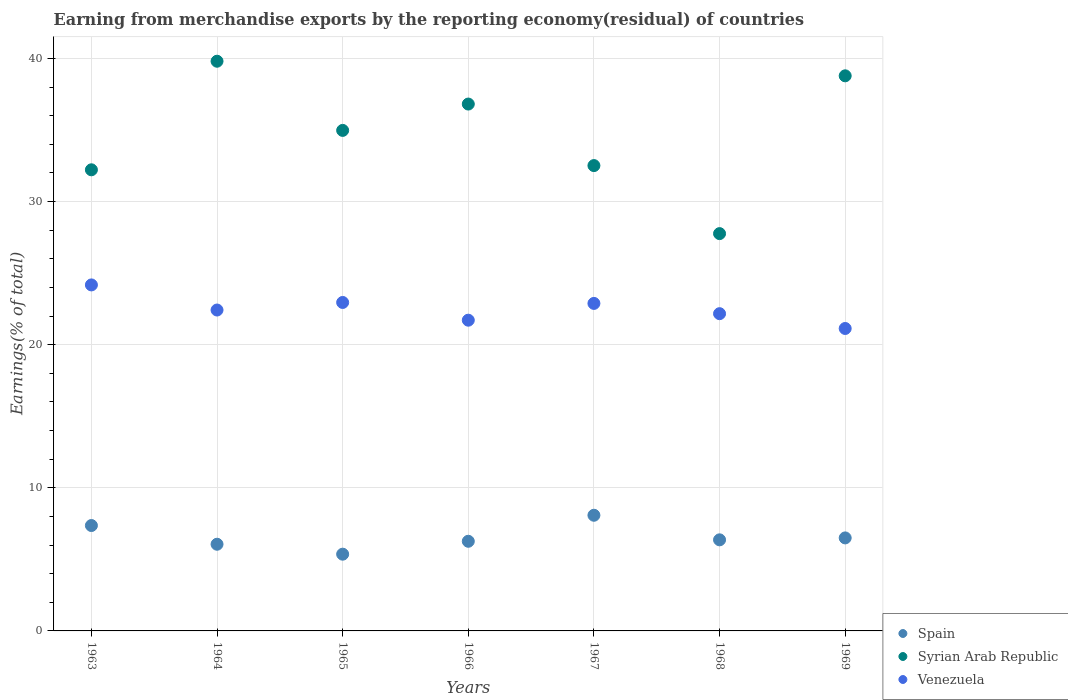What is the percentage of amount earned from merchandise exports in Venezuela in 1963?
Offer a terse response. 24.18. Across all years, what is the maximum percentage of amount earned from merchandise exports in Syrian Arab Republic?
Your response must be concise. 39.81. Across all years, what is the minimum percentage of amount earned from merchandise exports in Venezuela?
Your response must be concise. 21.13. In which year was the percentage of amount earned from merchandise exports in Syrian Arab Republic maximum?
Offer a very short reply. 1964. In which year was the percentage of amount earned from merchandise exports in Spain minimum?
Offer a terse response. 1965. What is the total percentage of amount earned from merchandise exports in Syrian Arab Republic in the graph?
Your answer should be compact. 242.88. What is the difference between the percentage of amount earned from merchandise exports in Syrian Arab Republic in 1964 and that in 1969?
Offer a very short reply. 1.02. What is the difference between the percentage of amount earned from merchandise exports in Venezuela in 1966 and the percentage of amount earned from merchandise exports in Spain in 1963?
Your answer should be very brief. 14.35. What is the average percentage of amount earned from merchandise exports in Venezuela per year?
Provide a succinct answer. 22.49. In the year 1968, what is the difference between the percentage of amount earned from merchandise exports in Syrian Arab Republic and percentage of amount earned from merchandise exports in Spain?
Your response must be concise. 21.4. In how many years, is the percentage of amount earned from merchandise exports in Spain greater than 30 %?
Provide a short and direct response. 0. What is the ratio of the percentage of amount earned from merchandise exports in Spain in 1964 to that in 1969?
Your answer should be compact. 0.93. Is the percentage of amount earned from merchandise exports in Spain in 1968 less than that in 1969?
Provide a succinct answer. Yes. What is the difference between the highest and the second highest percentage of amount earned from merchandise exports in Syrian Arab Republic?
Your response must be concise. 1.02. What is the difference between the highest and the lowest percentage of amount earned from merchandise exports in Spain?
Give a very brief answer. 2.72. Is the sum of the percentage of amount earned from merchandise exports in Syrian Arab Republic in 1963 and 1968 greater than the maximum percentage of amount earned from merchandise exports in Venezuela across all years?
Your response must be concise. Yes. Is it the case that in every year, the sum of the percentage of amount earned from merchandise exports in Spain and percentage of amount earned from merchandise exports in Syrian Arab Republic  is greater than the percentage of amount earned from merchandise exports in Venezuela?
Offer a terse response. Yes. Does the percentage of amount earned from merchandise exports in Syrian Arab Republic monotonically increase over the years?
Make the answer very short. No. Is the percentage of amount earned from merchandise exports in Syrian Arab Republic strictly greater than the percentage of amount earned from merchandise exports in Venezuela over the years?
Your answer should be compact. Yes. Is the percentage of amount earned from merchandise exports in Syrian Arab Republic strictly less than the percentage of amount earned from merchandise exports in Spain over the years?
Your answer should be compact. No. How many years are there in the graph?
Keep it short and to the point. 7. Are the values on the major ticks of Y-axis written in scientific E-notation?
Your answer should be very brief. No. Does the graph contain grids?
Offer a terse response. Yes. How many legend labels are there?
Ensure brevity in your answer.  3. What is the title of the graph?
Offer a terse response. Earning from merchandise exports by the reporting economy(residual) of countries. What is the label or title of the X-axis?
Provide a succinct answer. Years. What is the label or title of the Y-axis?
Provide a short and direct response. Earnings(% of total). What is the Earnings(% of total) of Spain in 1963?
Your answer should be compact. 7.36. What is the Earnings(% of total) of Syrian Arab Republic in 1963?
Your answer should be very brief. 32.22. What is the Earnings(% of total) of Venezuela in 1963?
Your answer should be compact. 24.18. What is the Earnings(% of total) of Spain in 1964?
Provide a short and direct response. 6.06. What is the Earnings(% of total) in Syrian Arab Republic in 1964?
Provide a succinct answer. 39.81. What is the Earnings(% of total) in Venezuela in 1964?
Keep it short and to the point. 22.42. What is the Earnings(% of total) in Spain in 1965?
Your answer should be very brief. 5.36. What is the Earnings(% of total) of Syrian Arab Republic in 1965?
Make the answer very short. 34.97. What is the Earnings(% of total) in Venezuela in 1965?
Offer a very short reply. 22.95. What is the Earnings(% of total) in Spain in 1966?
Your answer should be very brief. 6.26. What is the Earnings(% of total) in Syrian Arab Republic in 1966?
Keep it short and to the point. 36.81. What is the Earnings(% of total) in Venezuela in 1966?
Make the answer very short. 21.71. What is the Earnings(% of total) of Spain in 1967?
Your answer should be very brief. 8.08. What is the Earnings(% of total) in Syrian Arab Republic in 1967?
Offer a very short reply. 32.51. What is the Earnings(% of total) in Venezuela in 1967?
Ensure brevity in your answer.  22.88. What is the Earnings(% of total) in Spain in 1968?
Provide a short and direct response. 6.36. What is the Earnings(% of total) in Syrian Arab Republic in 1968?
Offer a very short reply. 27.76. What is the Earnings(% of total) of Venezuela in 1968?
Offer a very short reply. 22.17. What is the Earnings(% of total) in Spain in 1969?
Offer a terse response. 6.5. What is the Earnings(% of total) of Syrian Arab Republic in 1969?
Your response must be concise. 38.79. What is the Earnings(% of total) in Venezuela in 1969?
Offer a very short reply. 21.13. Across all years, what is the maximum Earnings(% of total) in Spain?
Ensure brevity in your answer.  8.08. Across all years, what is the maximum Earnings(% of total) in Syrian Arab Republic?
Your answer should be compact. 39.81. Across all years, what is the maximum Earnings(% of total) of Venezuela?
Keep it short and to the point. 24.18. Across all years, what is the minimum Earnings(% of total) in Spain?
Your answer should be very brief. 5.36. Across all years, what is the minimum Earnings(% of total) in Syrian Arab Republic?
Offer a terse response. 27.76. Across all years, what is the minimum Earnings(% of total) in Venezuela?
Give a very brief answer. 21.13. What is the total Earnings(% of total) in Spain in the graph?
Provide a short and direct response. 45.99. What is the total Earnings(% of total) in Syrian Arab Republic in the graph?
Keep it short and to the point. 242.88. What is the total Earnings(% of total) of Venezuela in the graph?
Your response must be concise. 157.45. What is the difference between the Earnings(% of total) of Spain in 1963 and that in 1964?
Offer a terse response. 1.31. What is the difference between the Earnings(% of total) of Syrian Arab Republic in 1963 and that in 1964?
Provide a succinct answer. -7.59. What is the difference between the Earnings(% of total) in Venezuela in 1963 and that in 1964?
Offer a terse response. 1.75. What is the difference between the Earnings(% of total) in Spain in 1963 and that in 1965?
Offer a very short reply. 2. What is the difference between the Earnings(% of total) in Syrian Arab Republic in 1963 and that in 1965?
Your answer should be very brief. -2.75. What is the difference between the Earnings(% of total) of Venezuela in 1963 and that in 1965?
Offer a very short reply. 1.23. What is the difference between the Earnings(% of total) of Spain in 1963 and that in 1966?
Offer a terse response. 1.1. What is the difference between the Earnings(% of total) in Syrian Arab Republic in 1963 and that in 1966?
Offer a terse response. -4.59. What is the difference between the Earnings(% of total) of Venezuela in 1963 and that in 1966?
Your answer should be compact. 2.46. What is the difference between the Earnings(% of total) in Spain in 1963 and that in 1967?
Your answer should be compact. -0.72. What is the difference between the Earnings(% of total) of Syrian Arab Republic in 1963 and that in 1967?
Offer a terse response. -0.29. What is the difference between the Earnings(% of total) of Venezuela in 1963 and that in 1967?
Make the answer very short. 1.29. What is the difference between the Earnings(% of total) in Syrian Arab Republic in 1963 and that in 1968?
Offer a very short reply. 4.46. What is the difference between the Earnings(% of total) in Venezuela in 1963 and that in 1968?
Your response must be concise. 2.01. What is the difference between the Earnings(% of total) in Spain in 1963 and that in 1969?
Offer a terse response. 0.86. What is the difference between the Earnings(% of total) in Syrian Arab Republic in 1963 and that in 1969?
Give a very brief answer. -6.57. What is the difference between the Earnings(% of total) of Venezuela in 1963 and that in 1969?
Offer a terse response. 3.04. What is the difference between the Earnings(% of total) in Spain in 1964 and that in 1965?
Give a very brief answer. 0.69. What is the difference between the Earnings(% of total) of Syrian Arab Republic in 1964 and that in 1965?
Offer a very short reply. 4.83. What is the difference between the Earnings(% of total) in Venezuela in 1964 and that in 1965?
Offer a very short reply. -0.53. What is the difference between the Earnings(% of total) in Spain in 1964 and that in 1966?
Your response must be concise. -0.21. What is the difference between the Earnings(% of total) of Syrian Arab Republic in 1964 and that in 1966?
Offer a terse response. 2.99. What is the difference between the Earnings(% of total) in Venezuela in 1964 and that in 1966?
Give a very brief answer. 0.71. What is the difference between the Earnings(% of total) of Spain in 1964 and that in 1967?
Offer a terse response. -2.02. What is the difference between the Earnings(% of total) in Syrian Arab Republic in 1964 and that in 1967?
Your response must be concise. 7.29. What is the difference between the Earnings(% of total) in Venezuela in 1964 and that in 1967?
Offer a very short reply. -0.46. What is the difference between the Earnings(% of total) in Spain in 1964 and that in 1968?
Provide a succinct answer. -0.31. What is the difference between the Earnings(% of total) of Syrian Arab Republic in 1964 and that in 1968?
Your response must be concise. 12.05. What is the difference between the Earnings(% of total) in Venezuela in 1964 and that in 1968?
Provide a succinct answer. 0.25. What is the difference between the Earnings(% of total) in Spain in 1964 and that in 1969?
Provide a succinct answer. -0.44. What is the difference between the Earnings(% of total) of Syrian Arab Republic in 1964 and that in 1969?
Give a very brief answer. 1.02. What is the difference between the Earnings(% of total) in Venezuela in 1964 and that in 1969?
Provide a succinct answer. 1.29. What is the difference between the Earnings(% of total) of Spain in 1965 and that in 1966?
Provide a short and direct response. -0.9. What is the difference between the Earnings(% of total) of Syrian Arab Republic in 1965 and that in 1966?
Provide a succinct answer. -1.84. What is the difference between the Earnings(% of total) in Venezuela in 1965 and that in 1966?
Ensure brevity in your answer.  1.24. What is the difference between the Earnings(% of total) in Spain in 1965 and that in 1967?
Provide a succinct answer. -2.72. What is the difference between the Earnings(% of total) in Syrian Arab Republic in 1965 and that in 1967?
Offer a terse response. 2.46. What is the difference between the Earnings(% of total) in Venezuela in 1965 and that in 1967?
Provide a succinct answer. 0.07. What is the difference between the Earnings(% of total) of Spain in 1965 and that in 1968?
Give a very brief answer. -1. What is the difference between the Earnings(% of total) in Syrian Arab Republic in 1965 and that in 1968?
Offer a terse response. 7.21. What is the difference between the Earnings(% of total) in Venezuela in 1965 and that in 1968?
Keep it short and to the point. 0.78. What is the difference between the Earnings(% of total) in Spain in 1965 and that in 1969?
Your answer should be very brief. -1.14. What is the difference between the Earnings(% of total) of Syrian Arab Republic in 1965 and that in 1969?
Offer a very short reply. -3.81. What is the difference between the Earnings(% of total) of Venezuela in 1965 and that in 1969?
Your response must be concise. 1.82. What is the difference between the Earnings(% of total) in Spain in 1966 and that in 1967?
Keep it short and to the point. -1.82. What is the difference between the Earnings(% of total) of Syrian Arab Republic in 1966 and that in 1967?
Make the answer very short. 4.3. What is the difference between the Earnings(% of total) of Venezuela in 1966 and that in 1967?
Provide a short and direct response. -1.17. What is the difference between the Earnings(% of total) in Spain in 1966 and that in 1968?
Your response must be concise. -0.1. What is the difference between the Earnings(% of total) in Syrian Arab Republic in 1966 and that in 1968?
Ensure brevity in your answer.  9.05. What is the difference between the Earnings(% of total) of Venezuela in 1966 and that in 1968?
Provide a succinct answer. -0.46. What is the difference between the Earnings(% of total) in Spain in 1966 and that in 1969?
Provide a short and direct response. -0.24. What is the difference between the Earnings(% of total) of Syrian Arab Republic in 1966 and that in 1969?
Your answer should be compact. -1.97. What is the difference between the Earnings(% of total) in Venezuela in 1966 and that in 1969?
Your answer should be very brief. 0.58. What is the difference between the Earnings(% of total) in Spain in 1967 and that in 1968?
Give a very brief answer. 1.72. What is the difference between the Earnings(% of total) of Syrian Arab Republic in 1967 and that in 1968?
Offer a terse response. 4.75. What is the difference between the Earnings(% of total) of Venezuela in 1967 and that in 1968?
Make the answer very short. 0.72. What is the difference between the Earnings(% of total) in Spain in 1967 and that in 1969?
Offer a very short reply. 1.58. What is the difference between the Earnings(% of total) of Syrian Arab Republic in 1967 and that in 1969?
Offer a terse response. -6.27. What is the difference between the Earnings(% of total) of Venezuela in 1967 and that in 1969?
Provide a succinct answer. 1.75. What is the difference between the Earnings(% of total) of Spain in 1968 and that in 1969?
Provide a succinct answer. -0.13. What is the difference between the Earnings(% of total) in Syrian Arab Republic in 1968 and that in 1969?
Offer a terse response. -11.03. What is the difference between the Earnings(% of total) in Venezuela in 1968 and that in 1969?
Your answer should be very brief. 1.03. What is the difference between the Earnings(% of total) in Spain in 1963 and the Earnings(% of total) in Syrian Arab Republic in 1964?
Your answer should be very brief. -32.44. What is the difference between the Earnings(% of total) of Spain in 1963 and the Earnings(% of total) of Venezuela in 1964?
Your answer should be very brief. -15.06. What is the difference between the Earnings(% of total) in Syrian Arab Republic in 1963 and the Earnings(% of total) in Venezuela in 1964?
Ensure brevity in your answer.  9.8. What is the difference between the Earnings(% of total) in Spain in 1963 and the Earnings(% of total) in Syrian Arab Republic in 1965?
Offer a very short reply. -27.61. What is the difference between the Earnings(% of total) of Spain in 1963 and the Earnings(% of total) of Venezuela in 1965?
Your response must be concise. -15.59. What is the difference between the Earnings(% of total) in Syrian Arab Republic in 1963 and the Earnings(% of total) in Venezuela in 1965?
Give a very brief answer. 9.27. What is the difference between the Earnings(% of total) of Spain in 1963 and the Earnings(% of total) of Syrian Arab Republic in 1966?
Keep it short and to the point. -29.45. What is the difference between the Earnings(% of total) of Spain in 1963 and the Earnings(% of total) of Venezuela in 1966?
Keep it short and to the point. -14.35. What is the difference between the Earnings(% of total) of Syrian Arab Republic in 1963 and the Earnings(% of total) of Venezuela in 1966?
Give a very brief answer. 10.51. What is the difference between the Earnings(% of total) of Spain in 1963 and the Earnings(% of total) of Syrian Arab Republic in 1967?
Your response must be concise. -25.15. What is the difference between the Earnings(% of total) of Spain in 1963 and the Earnings(% of total) of Venezuela in 1967?
Keep it short and to the point. -15.52. What is the difference between the Earnings(% of total) in Syrian Arab Republic in 1963 and the Earnings(% of total) in Venezuela in 1967?
Your answer should be very brief. 9.34. What is the difference between the Earnings(% of total) in Spain in 1963 and the Earnings(% of total) in Syrian Arab Republic in 1968?
Offer a terse response. -20.4. What is the difference between the Earnings(% of total) in Spain in 1963 and the Earnings(% of total) in Venezuela in 1968?
Keep it short and to the point. -14.8. What is the difference between the Earnings(% of total) in Syrian Arab Republic in 1963 and the Earnings(% of total) in Venezuela in 1968?
Your answer should be compact. 10.05. What is the difference between the Earnings(% of total) of Spain in 1963 and the Earnings(% of total) of Syrian Arab Republic in 1969?
Give a very brief answer. -31.42. What is the difference between the Earnings(% of total) in Spain in 1963 and the Earnings(% of total) in Venezuela in 1969?
Offer a very short reply. -13.77. What is the difference between the Earnings(% of total) in Syrian Arab Republic in 1963 and the Earnings(% of total) in Venezuela in 1969?
Make the answer very short. 11.09. What is the difference between the Earnings(% of total) of Spain in 1964 and the Earnings(% of total) of Syrian Arab Republic in 1965?
Offer a very short reply. -28.92. What is the difference between the Earnings(% of total) in Spain in 1964 and the Earnings(% of total) in Venezuela in 1965?
Give a very brief answer. -16.89. What is the difference between the Earnings(% of total) of Syrian Arab Republic in 1964 and the Earnings(% of total) of Venezuela in 1965?
Ensure brevity in your answer.  16.86. What is the difference between the Earnings(% of total) of Spain in 1964 and the Earnings(% of total) of Syrian Arab Republic in 1966?
Give a very brief answer. -30.76. What is the difference between the Earnings(% of total) of Spain in 1964 and the Earnings(% of total) of Venezuela in 1966?
Provide a succinct answer. -15.66. What is the difference between the Earnings(% of total) in Syrian Arab Republic in 1964 and the Earnings(% of total) in Venezuela in 1966?
Keep it short and to the point. 18.09. What is the difference between the Earnings(% of total) of Spain in 1964 and the Earnings(% of total) of Syrian Arab Republic in 1967?
Provide a succinct answer. -26.46. What is the difference between the Earnings(% of total) of Spain in 1964 and the Earnings(% of total) of Venezuela in 1967?
Offer a very short reply. -16.83. What is the difference between the Earnings(% of total) in Syrian Arab Republic in 1964 and the Earnings(% of total) in Venezuela in 1967?
Provide a short and direct response. 16.92. What is the difference between the Earnings(% of total) in Spain in 1964 and the Earnings(% of total) in Syrian Arab Republic in 1968?
Offer a very short reply. -21.7. What is the difference between the Earnings(% of total) of Spain in 1964 and the Earnings(% of total) of Venezuela in 1968?
Give a very brief answer. -16.11. What is the difference between the Earnings(% of total) of Syrian Arab Republic in 1964 and the Earnings(% of total) of Venezuela in 1968?
Give a very brief answer. 17.64. What is the difference between the Earnings(% of total) of Spain in 1964 and the Earnings(% of total) of Syrian Arab Republic in 1969?
Your response must be concise. -32.73. What is the difference between the Earnings(% of total) of Spain in 1964 and the Earnings(% of total) of Venezuela in 1969?
Give a very brief answer. -15.08. What is the difference between the Earnings(% of total) of Syrian Arab Republic in 1964 and the Earnings(% of total) of Venezuela in 1969?
Make the answer very short. 18.67. What is the difference between the Earnings(% of total) in Spain in 1965 and the Earnings(% of total) in Syrian Arab Republic in 1966?
Offer a very short reply. -31.45. What is the difference between the Earnings(% of total) of Spain in 1965 and the Earnings(% of total) of Venezuela in 1966?
Ensure brevity in your answer.  -16.35. What is the difference between the Earnings(% of total) in Syrian Arab Republic in 1965 and the Earnings(% of total) in Venezuela in 1966?
Keep it short and to the point. 13.26. What is the difference between the Earnings(% of total) in Spain in 1965 and the Earnings(% of total) in Syrian Arab Republic in 1967?
Make the answer very short. -27.15. What is the difference between the Earnings(% of total) of Spain in 1965 and the Earnings(% of total) of Venezuela in 1967?
Make the answer very short. -17.52. What is the difference between the Earnings(% of total) in Syrian Arab Republic in 1965 and the Earnings(% of total) in Venezuela in 1967?
Your response must be concise. 12.09. What is the difference between the Earnings(% of total) of Spain in 1965 and the Earnings(% of total) of Syrian Arab Republic in 1968?
Your answer should be compact. -22.4. What is the difference between the Earnings(% of total) in Spain in 1965 and the Earnings(% of total) in Venezuela in 1968?
Your answer should be very brief. -16.81. What is the difference between the Earnings(% of total) in Syrian Arab Republic in 1965 and the Earnings(% of total) in Venezuela in 1968?
Offer a terse response. 12.81. What is the difference between the Earnings(% of total) of Spain in 1965 and the Earnings(% of total) of Syrian Arab Republic in 1969?
Make the answer very short. -33.43. What is the difference between the Earnings(% of total) in Spain in 1965 and the Earnings(% of total) in Venezuela in 1969?
Ensure brevity in your answer.  -15.77. What is the difference between the Earnings(% of total) of Syrian Arab Republic in 1965 and the Earnings(% of total) of Venezuela in 1969?
Your answer should be compact. 13.84. What is the difference between the Earnings(% of total) of Spain in 1966 and the Earnings(% of total) of Syrian Arab Republic in 1967?
Offer a terse response. -26.25. What is the difference between the Earnings(% of total) in Spain in 1966 and the Earnings(% of total) in Venezuela in 1967?
Your answer should be very brief. -16.62. What is the difference between the Earnings(% of total) of Syrian Arab Republic in 1966 and the Earnings(% of total) of Venezuela in 1967?
Provide a short and direct response. 13.93. What is the difference between the Earnings(% of total) of Spain in 1966 and the Earnings(% of total) of Syrian Arab Republic in 1968?
Provide a succinct answer. -21.5. What is the difference between the Earnings(% of total) in Spain in 1966 and the Earnings(% of total) in Venezuela in 1968?
Give a very brief answer. -15.9. What is the difference between the Earnings(% of total) of Syrian Arab Republic in 1966 and the Earnings(% of total) of Venezuela in 1968?
Keep it short and to the point. 14.65. What is the difference between the Earnings(% of total) in Spain in 1966 and the Earnings(% of total) in Syrian Arab Republic in 1969?
Offer a very short reply. -32.52. What is the difference between the Earnings(% of total) in Spain in 1966 and the Earnings(% of total) in Venezuela in 1969?
Give a very brief answer. -14.87. What is the difference between the Earnings(% of total) of Syrian Arab Republic in 1966 and the Earnings(% of total) of Venezuela in 1969?
Provide a short and direct response. 15.68. What is the difference between the Earnings(% of total) in Spain in 1967 and the Earnings(% of total) in Syrian Arab Republic in 1968?
Offer a terse response. -19.68. What is the difference between the Earnings(% of total) in Spain in 1967 and the Earnings(% of total) in Venezuela in 1968?
Ensure brevity in your answer.  -14.09. What is the difference between the Earnings(% of total) in Syrian Arab Republic in 1967 and the Earnings(% of total) in Venezuela in 1968?
Offer a terse response. 10.35. What is the difference between the Earnings(% of total) of Spain in 1967 and the Earnings(% of total) of Syrian Arab Republic in 1969?
Offer a terse response. -30.71. What is the difference between the Earnings(% of total) in Spain in 1967 and the Earnings(% of total) in Venezuela in 1969?
Offer a very short reply. -13.05. What is the difference between the Earnings(% of total) of Syrian Arab Republic in 1967 and the Earnings(% of total) of Venezuela in 1969?
Your answer should be compact. 11.38. What is the difference between the Earnings(% of total) in Spain in 1968 and the Earnings(% of total) in Syrian Arab Republic in 1969?
Provide a short and direct response. -32.42. What is the difference between the Earnings(% of total) in Spain in 1968 and the Earnings(% of total) in Venezuela in 1969?
Your answer should be compact. -14.77. What is the difference between the Earnings(% of total) in Syrian Arab Republic in 1968 and the Earnings(% of total) in Venezuela in 1969?
Your answer should be compact. 6.63. What is the average Earnings(% of total) of Spain per year?
Your answer should be compact. 6.57. What is the average Earnings(% of total) of Syrian Arab Republic per year?
Give a very brief answer. 34.7. What is the average Earnings(% of total) in Venezuela per year?
Your response must be concise. 22.49. In the year 1963, what is the difference between the Earnings(% of total) in Spain and Earnings(% of total) in Syrian Arab Republic?
Your answer should be very brief. -24.86. In the year 1963, what is the difference between the Earnings(% of total) in Spain and Earnings(% of total) in Venezuela?
Offer a terse response. -16.81. In the year 1963, what is the difference between the Earnings(% of total) in Syrian Arab Republic and Earnings(% of total) in Venezuela?
Ensure brevity in your answer.  8.04. In the year 1964, what is the difference between the Earnings(% of total) of Spain and Earnings(% of total) of Syrian Arab Republic?
Provide a short and direct response. -33.75. In the year 1964, what is the difference between the Earnings(% of total) in Spain and Earnings(% of total) in Venezuela?
Provide a short and direct response. -16.37. In the year 1964, what is the difference between the Earnings(% of total) in Syrian Arab Republic and Earnings(% of total) in Venezuela?
Your answer should be very brief. 17.38. In the year 1965, what is the difference between the Earnings(% of total) in Spain and Earnings(% of total) in Syrian Arab Republic?
Offer a terse response. -29.61. In the year 1965, what is the difference between the Earnings(% of total) of Spain and Earnings(% of total) of Venezuela?
Make the answer very short. -17.59. In the year 1965, what is the difference between the Earnings(% of total) of Syrian Arab Republic and Earnings(% of total) of Venezuela?
Provide a succinct answer. 12.02. In the year 1966, what is the difference between the Earnings(% of total) of Spain and Earnings(% of total) of Syrian Arab Republic?
Your answer should be compact. -30.55. In the year 1966, what is the difference between the Earnings(% of total) of Spain and Earnings(% of total) of Venezuela?
Provide a succinct answer. -15.45. In the year 1966, what is the difference between the Earnings(% of total) in Syrian Arab Republic and Earnings(% of total) in Venezuela?
Make the answer very short. 15.1. In the year 1967, what is the difference between the Earnings(% of total) of Spain and Earnings(% of total) of Syrian Arab Republic?
Provide a succinct answer. -24.43. In the year 1967, what is the difference between the Earnings(% of total) in Spain and Earnings(% of total) in Venezuela?
Offer a very short reply. -14.8. In the year 1967, what is the difference between the Earnings(% of total) of Syrian Arab Republic and Earnings(% of total) of Venezuela?
Offer a very short reply. 9.63. In the year 1968, what is the difference between the Earnings(% of total) of Spain and Earnings(% of total) of Syrian Arab Republic?
Provide a short and direct response. -21.4. In the year 1968, what is the difference between the Earnings(% of total) in Spain and Earnings(% of total) in Venezuela?
Give a very brief answer. -15.8. In the year 1968, what is the difference between the Earnings(% of total) in Syrian Arab Republic and Earnings(% of total) in Venezuela?
Offer a terse response. 5.59. In the year 1969, what is the difference between the Earnings(% of total) in Spain and Earnings(% of total) in Syrian Arab Republic?
Offer a very short reply. -32.29. In the year 1969, what is the difference between the Earnings(% of total) of Spain and Earnings(% of total) of Venezuela?
Ensure brevity in your answer.  -14.63. In the year 1969, what is the difference between the Earnings(% of total) in Syrian Arab Republic and Earnings(% of total) in Venezuela?
Offer a terse response. 17.65. What is the ratio of the Earnings(% of total) of Spain in 1963 to that in 1964?
Make the answer very short. 1.22. What is the ratio of the Earnings(% of total) in Syrian Arab Republic in 1963 to that in 1964?
Offer a very short reply. 0.81. What is the ratio of the Earnings(% of total) of Venezuela in 1963 to that in 1964?
Provide a short and direct response. 1.08. What is the ratio of the Earnings(% of total) in Spain in 1963 to that in 1965?
Make the answer very short. 1.37. What is the ratio of the Earnings(% of total) of Syrian Arab Republic in 1963 to that in 1965?
Offer a terse response. 0.92. What is the ratio of the Earnings(% of total) of Venezuela in 1963 to that in 1965?
Your answer should be compact. 1.05. What is the ratio of the Earnings(% of total) in Spain in 1963 to that in 1966?
Give a very brief answer. 1.18. What is the ratio of the Earnings(% of total) in Syrian Arab Republic in 1963 to that in 1966?
Offer a terse response. 0.88. What is the ratio of the Earnings(% of total) of Venezuela in 1963 to that in 1966?
Keep it short and to the point. 1.11. What is the ratio of the Earnings(% of total) of Spain in 1963 to that in 1967?
Your answer should be compact. 0.91. What is the ratio of the Earnings(% of total) in Venezuela in 1963 to that in 1967?
Keep it short and to the point. 1.06. What is the ratio of the Earnings(% of total) in Spain in 1963 to that in 1968?
Your response must be concise. 1.16. What is the ratio of the Earnings(% of total) in Syrian Arab Republic in 1963 to that in 1968?
Keep it short and to the point. 1.16. What is the ratio of the Earnings(% of total) of Venezuela in 1963 to that in 1968?
Your response must be concise. 1.09. What is the ratio of the Earnings(% of total) of Spain in 1963 to that in 1969?
Provide a short and direct response. 1.13. What is the ratio of the Earnings(% of total) of Syrian Arab Republic in 1963 to that in 1969?
Your answer should be very brief. 0.83. What is the ratio of the Earnings(% of total) in Venezuela in 1963 to that in 1969?
Your response must be concise. 1.14. What is the ratio of the Earnings(% of total) of Spain in 1964 to that in 1965?
Offer a terse response. 1.13. What is the ratio of the Earnings(% of total) of Syrian Arab Republic in 1964 to that in 1965?
Ensure brevity in your answer.  1.14. What is the ratio of the Earnings(% of total) of Venezuela in 1964 to that in 1965?
Your response must be concise. 0.98. What is the ratio of the Earnings(% of total) of Spain in 1964 to that in 1966?
Your answer should be compact. 0.97. What is the ratio of the Earnings(% of total) in Syrian Arab Republic in 1964 to that in 1966?
Offer a terse response. 1.08. What is the ratio of the Earnings(% of total) of Venezuela in 1964 to that in 1966?
Your answer should be compact. 1.03. What is the ratio of the Earnings(% of total) of Spain in 1964 to that in 1967?
Offer a very short reply. 0.75. What is the ratio of the Earnings(% of total) of Syrian Arab Republic in 1964 to that in 1967?
Make the answer very short. 1.22. What is the ratio of the Earnings(% of total) of Venezuela in 1964 to that in 1967?
Offer a terse response. 0.98. What is the ratio of the Earnings(% of total) in Spain in 1964 to that in 1968?
Your response must be concise. 0.95. What is the ratio of the Earnings(% of total) of Syrian Arab Republic in 1964 to that in 1968?
Provide a short and direct response. 1.43. What is the ratio of the Earnings(% of total) of Venezuela in 1964 to that in 1968?
Make the answer very short. 1.01. What is the ratio of the Earnings(% of total) in Spain in 1964 to that in 1969?
Your answer should be very brief. 0.93. What is the ratio of the Earnings(% of total) of Syrian Arab Republic in 1964 to that in 1969?
Give a very brief answer. 1.03. What is the ratio of the Earnings(% of total) in Venezuela in 1964 to that in 1969?
Keep it short and to the point. 1.06. What is the ratio of the Earnings(% of total) in Spain in 1965 to that in 1966?
Make the answer very short. 0.86. What is the ratio of the Earnings(% of total) in Syrian Arab Republic in 1965 to that in 1966?
Keep it short and to the point. 0.95. What is the ratio of the Earnings(% of total) of Venezuela in 1965 to that in 1966?
Provide a succinct answer. 1.06. What is the ratio of the Earnings(% of total) in Spain in 1965 to that in 1967?
Provide a short and direct response. 0.66. What is the ratio of the Earnings(% of total) of Syrian Arab Republic in 1965 to that in 1967?
Provide a short and direct response. 1.08. What is the ratio of the Earnings(% of total) in Venezuela in 1965 to that in 1967?
Give a very brief answer. 1. What is the ratio of the Earnings(% of total) in Spain in 1965 to that in 1968?
Your answer should be compact. 0.84. What is the ratio of the Earnings(% of total) in Syrian Arab Republic in 1965 to that in 1968?
Make the answer very short. 1.26. What is the ratio of the Earnings(% of total) of Venezuela in 1965 to that in 1968?
Your answer should be very brief. 1.04. What is the ratio of the Earnings(% of total) in Spain in 1965 to that in 1969?
Offer a very short reply. 0.82. What is the ratio of the Earnings(% of total) of Syrian Arab Republic in 1965 to that in 1969?
Provide a succinct answer. 0.9. What is the ratio of the Earnings(% of total) of Venezuela in 1965 to that in 1969?
Provide a succinct answer. 1.09. What is the ratio of the Earnings(% of total) in Spain in 1966 to that in 1967?
Give a very brief answer. 0.78. What is the ratio of the Earnings(% of total) of Syrian Arab Republic in 1966 to that in 1967?
Your response must be concise. 1.13. What is the ratio of the Earnings(% of total) of Venezuela in 1966 to that in 1967?
Make the answer very short. 0.95. What is the ratio of the Earnings(% of total) in Spain in 1966 to that in 1968?
Your answer should be very brief. 0.98. What is the ratio of the Earnings(% of total) in Syrian Arab Republic in 1966 to that in 1968?
Make the answer very short. 1.33. What is the ratio of the Earnings(% of total) in Venezuela in 1966 to that in 1968?
Provide a short and direct response. 0.98. What is the ratio of the Earnings(% of total) in Spain in 1966 to that in 1969?
Keep it short and to the point. 0.96. What is the ratio of the Earnings(% of total) of Syrian Arab Republic in 1966 to that in 1969?
Your answer should be compact. 0.95. What is the ratio of the Earnings(% of total) in Venezuela in 1966 to that in 1969?
Keep it short and to the point. 1.03. What is the ratio of the Earnings(% of total) in Spain in 1967 to that in 1968?
Offer a very short reply. 1.27. What is the ratio of the Earnings(% of total) in Syrian Arab Republic in 1967 to that in 1968?
Your answer should be compact. 1.17. What is the ratio of the Earnings(% of total) in Venezuela in 1967 to that in 1968?
Provide a succinct answer. 1.03. What is the ratio of the Earnings(% of total) in Spain in 1967 to that in 1969?
Your answer should be very brief. 1.24. What is the ratio of the Earnings(% of total) of Syrian Arab Republic in 1967 to that in 1969?
Your response must be concise. 0.84. What is the ratio of the Earnings(% of total) of Venezuela in 1967 to that in 1969?
Ensure brevity in your answer.  1.08. What is the ratio of the Earnings(% of total) of Spain in 1968 to that in 1969?
Your answer should be very brief. 0.98. What is the ratio of the Earnings(% of total) in Syrian Arab Republic in 1968 to that in 1969?
Provide a succinct answer. 0.72. What is the ratio of the Earnings(% of total) of Venezuela in 1968 to that in 1969?
Your answer should be compact. 1.05. What is the difference between the highest and the second highest Earnings(% of total) of Spain?
Make the answer very short. 0.72. What is the difference between the highest and the second highest Earnings(% of total) in Syrian Arab Republic?
Make the answer very short. 1.02. What is the difference between the highest and the second highest Earnings(% of total) in Venezuela?
Provide a short and direct response. 1.23. What is the difference between the highest and the lowest Earnings(% of total) of Spain?
Keep it short and to the point. 2.72. What is the difference between the highest and the lowest Earnings(% of total) in Syrian Arab Republic?
Ensure brevity in your answer.  12.05. What is the difference between the highest and the lowest Earnings(% of total) of Venezuela?
Ensure brevity in your answer.  3.04. 